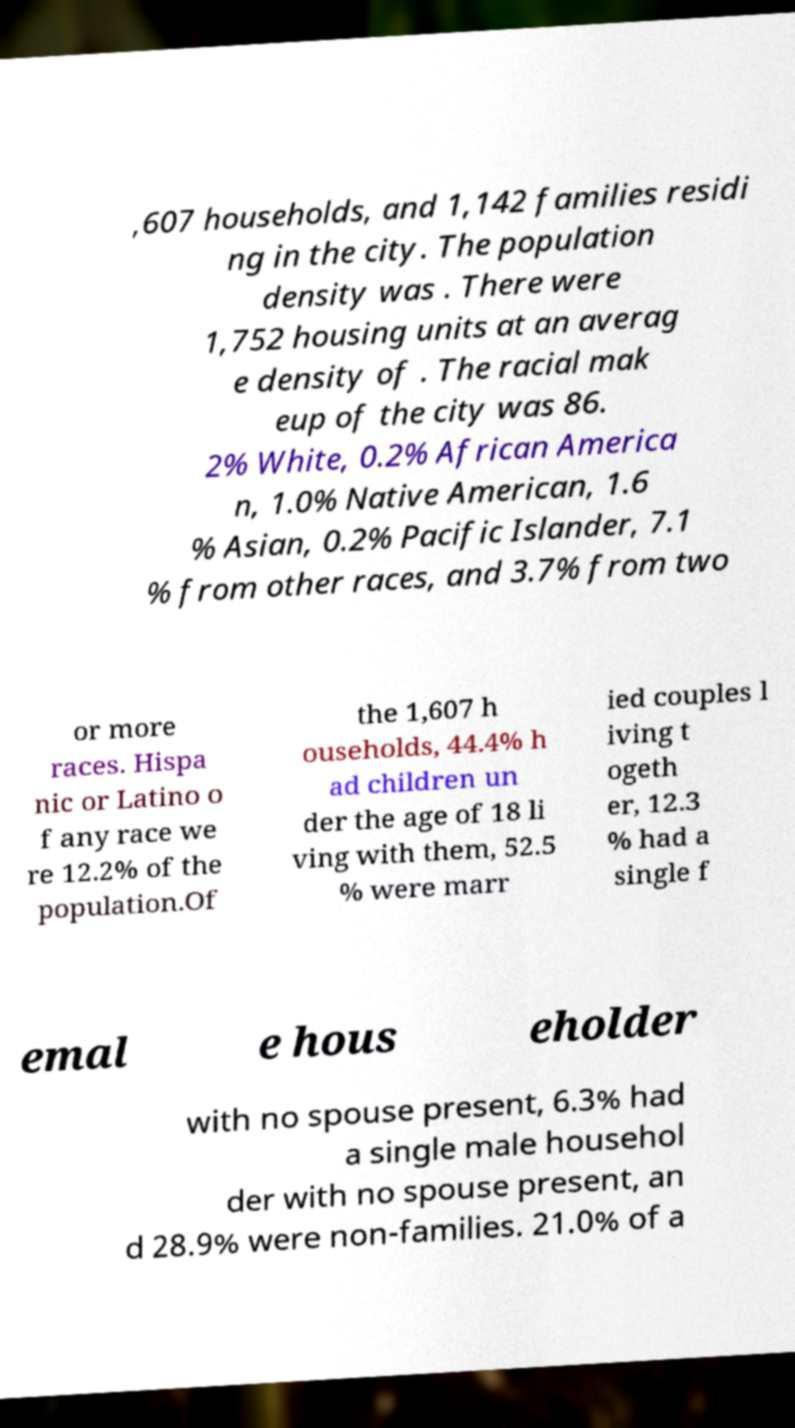Can you accurately transcribe the text from the provided image for me? ,607 households, and 1,142 families residi ng in the city. The population density was . There were 1,752 housing units at an averag e density of . The racial mak eup of the city was 86. 2% White, 0.2% African America n, 1.0% Native American, 1.6 % Asian, 0.2% Pacific Islander, 7.1 % from other races, and 3.7% from two or more races. Hispa nic or Latino o f any race we re 12.2% of the population.Of the 1,607 h ouseholds, 44.4% h ad children un der the age of 18 li ving with them, 52.5 % were marr ied couples l iving t ogeth er, 12.3 % had a single f emal e hous eholder with no spouse present, 6.3% had a single male househol der with no spouse present, an d 28.9% were non-families. 21.0% of a 